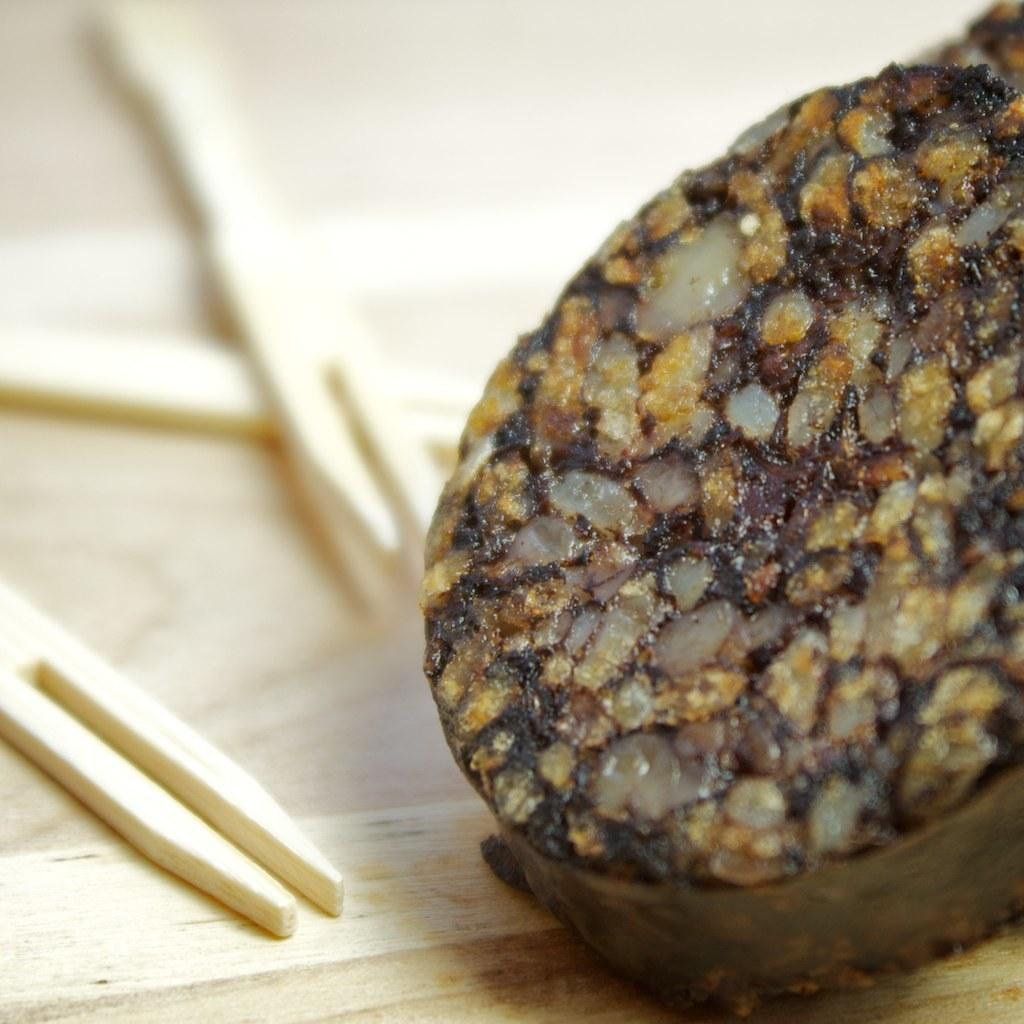What type of food is present in the image? There is a Black pudding in the image. What utensils or objects are visible in the image? Toothpicks are visible in the image. Are there any cobwebs visible in the image? There is no mention of cobwebs in the provided facts, and therefore we cannot determine if any are present in the image. How many balls are present in the image? There is no mention of balls in the provided facts, and therefore we cannot determine if any are present in the image. 